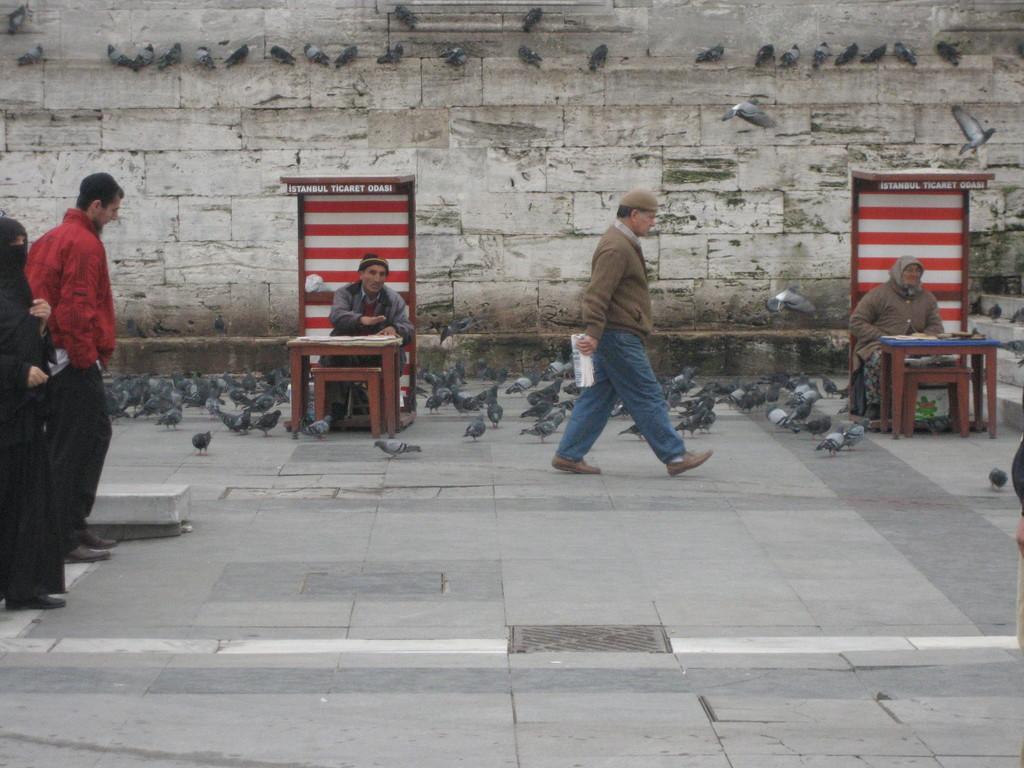In one or two sentences, can you explain what this image depicts? On the left side, there is a person in a red color jacket. Beside this person, there is a woman in a black color dress on the road. On the right side, there is a manhole on the road, on which there is a white color line. In the background, there are birds on a wall. 